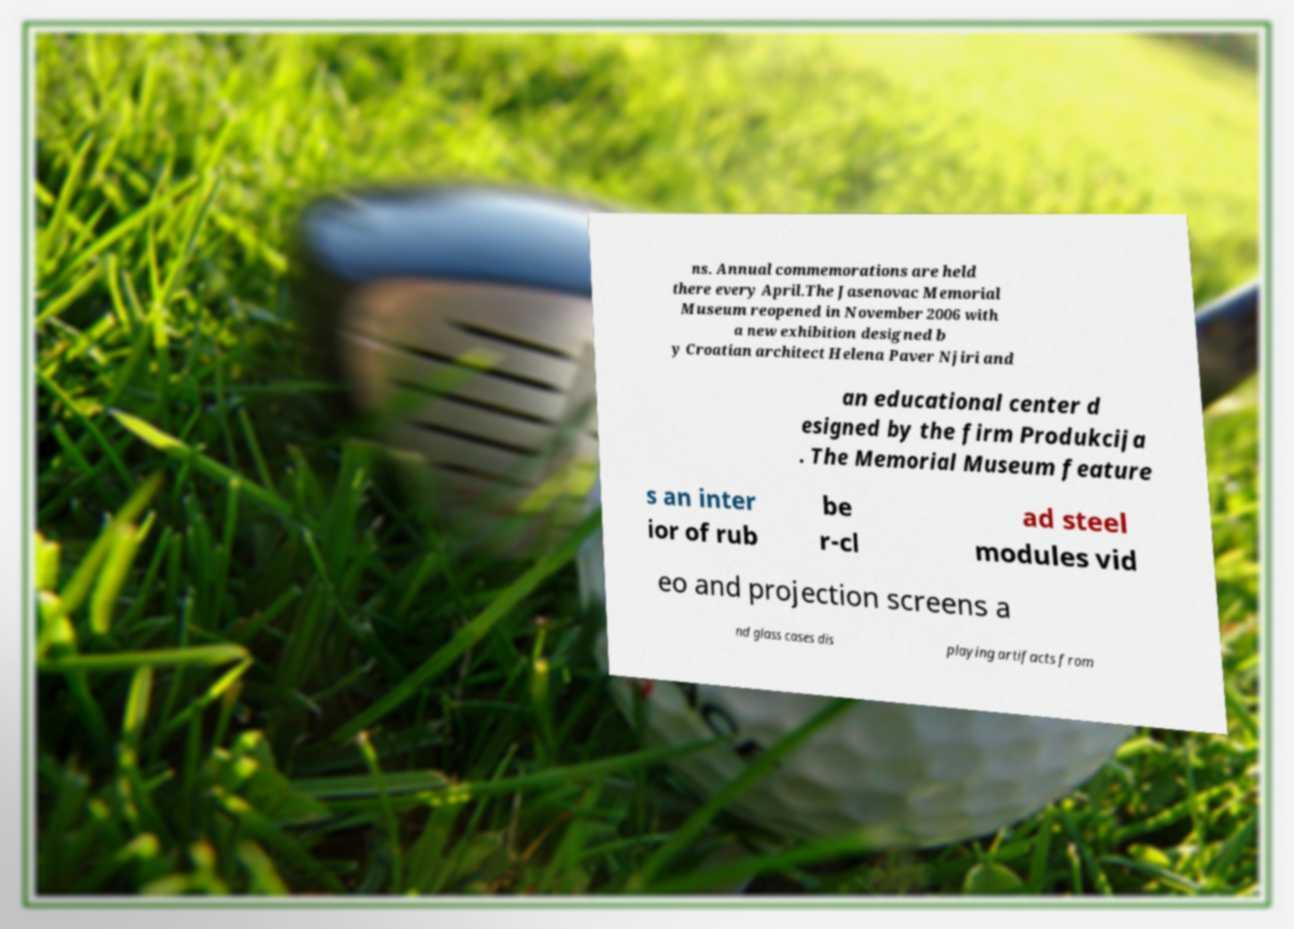Please read and relay the text visible in this image. What does it say? ns. Annual commemorations are held there every April.The Jasenovac Memorial Museum reopened in November 2006 with a new exhibition designed b y Croatian architect Helena Paver Njiri and an educational center d esigned by the firm Produkcija . The Memorial Museum feature s an inter ior of rub be r-cl ad steel modules vid eo and projection screens a nd glass cases dis playing artifacts from 